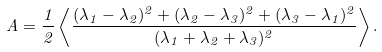Convert formula to latex. <formula><loc_0><loc_0><loc_500><loc_500>A = \frac { 1 } { 2 } \left \langle \frac { ( \lambda _ { 1 } - \lambda _ { 2 } ) ^ { 2 } + ( \lambda _ { 2 } - \lambda _ { 3 } ) ^ { 2 } + ( \lambda _ { 3 } - \lambda _ { 1 } ) ^ { 2 } } { ( \lambda _ { 1 } + \lambda _ { 2 } + \lambda _ { 3 } ) ^ { 2 } } \right \rangle .</formula> 